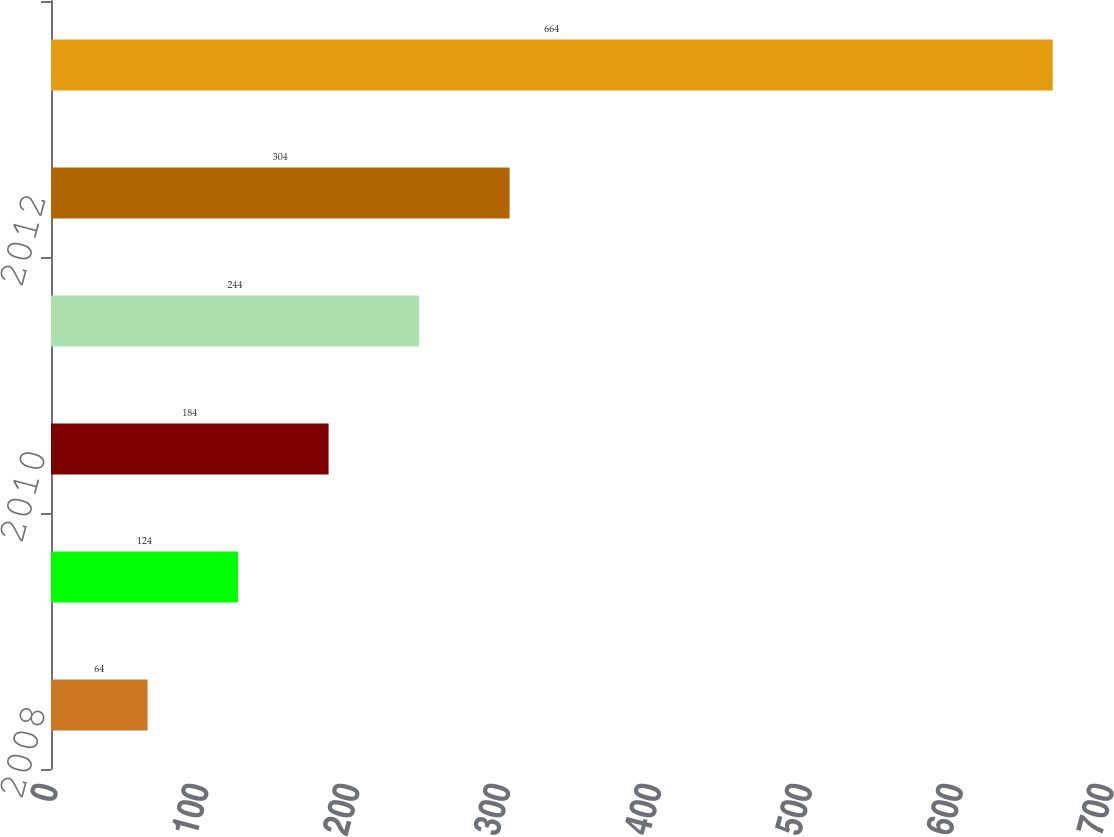<chart> <loc_0><loc_0><loc_500><loc_500><bar_chart><fcel>2008<fcel>2009<fcel>2010<fcel>2011<fcel>2012<fcel>2013-2017<nl><fcel>64<fcel>124<fcel>184<fcel>244<fcel>304<fcel>664<nl></chart> 